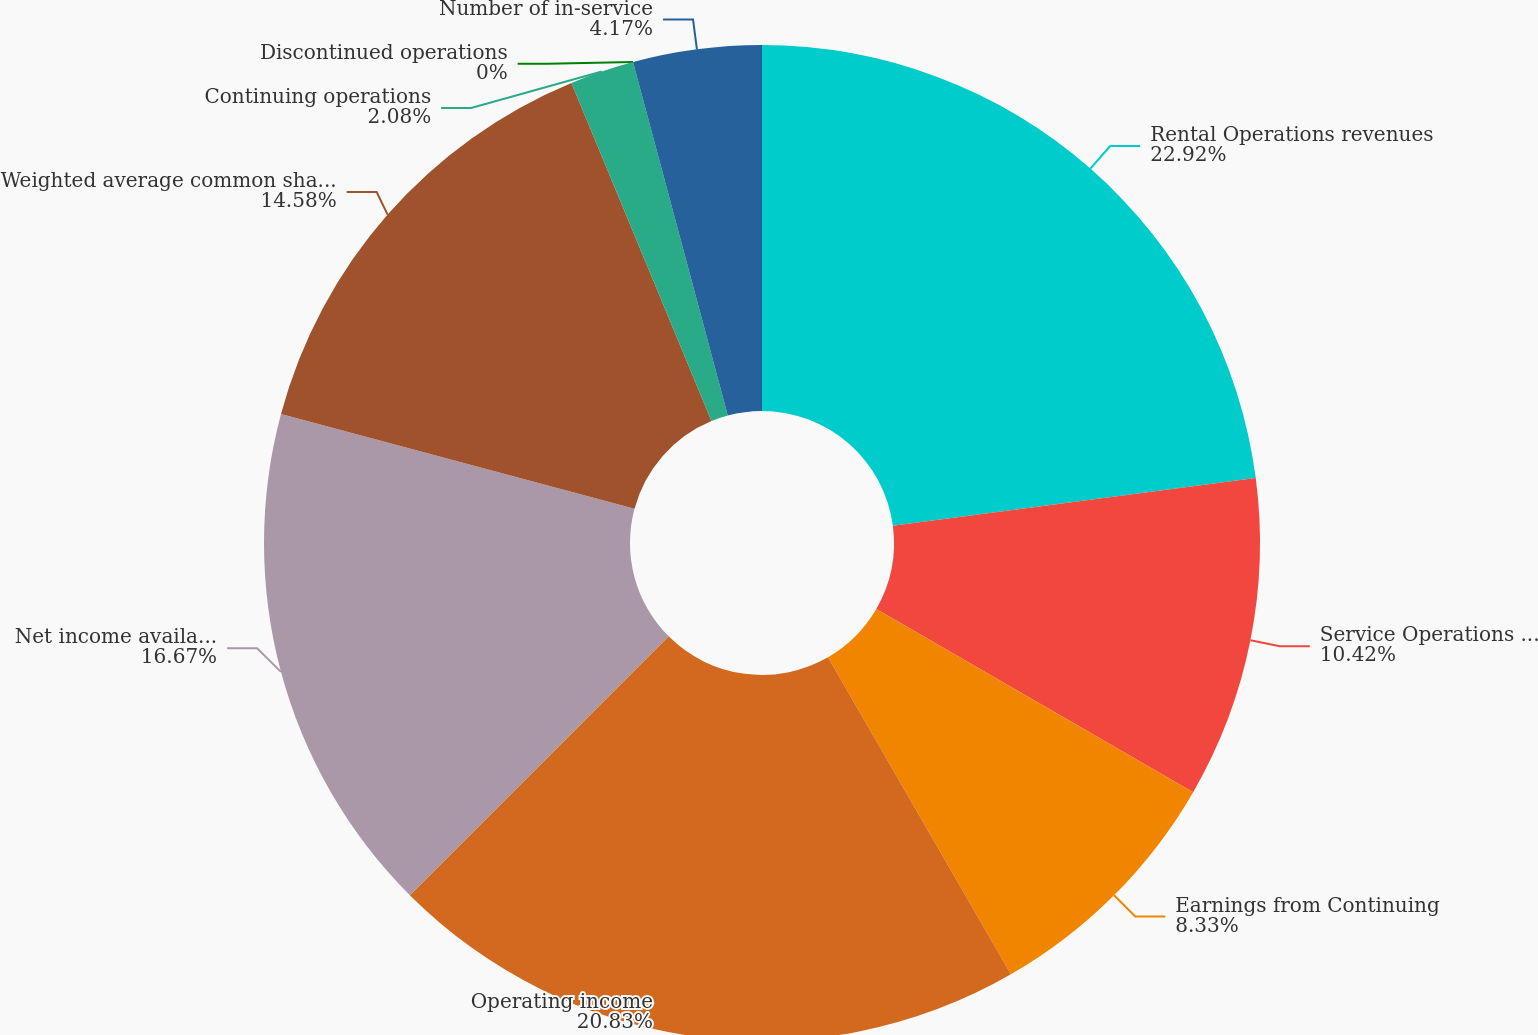<chart> <loc_0><loc_0><loc_500><loc_500><pie_chart><fcel>Rental Operations revenues<fcel>Service Operations revenues<fcel>Earnings from Continuing<fcel>Operating income<fcel>Net income available for<fcel>Weighted average common shares<fcel>Continuing operations<fcel>Discontinued operations<fcel>Number of in-service<nl><fcel>22.92%<fcel>10.42%<fcel>8.33%<fcel>20.83%<fcel>16.67%<fcel>14.58%<fcel>2.08%<fcel>0.0%<fcel>4.17%<nl></chart> 